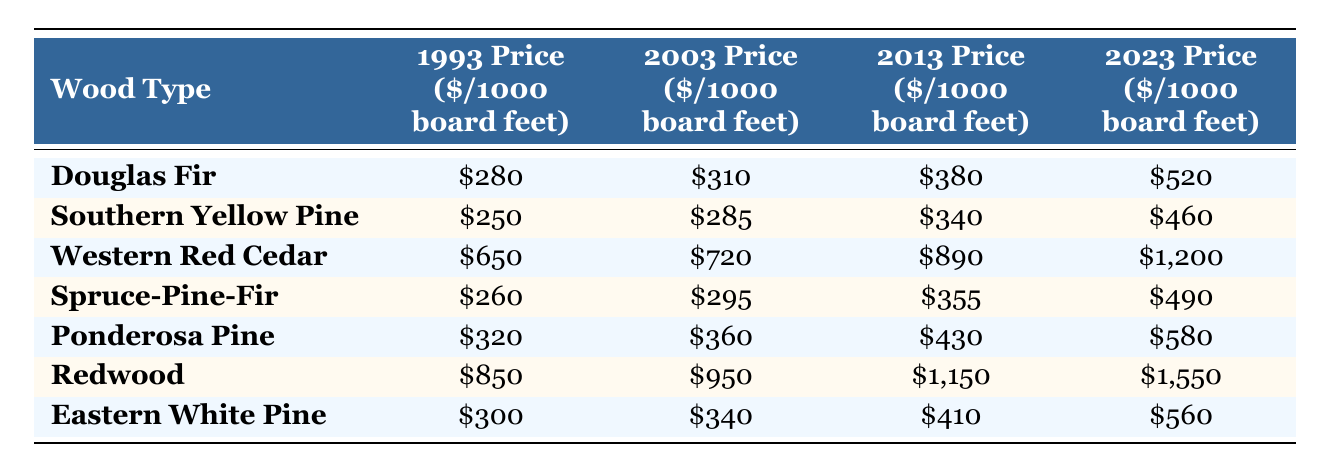What was the price of Western Red Cedar in 2023? The table shows that the price of Western Red Cedar in 2023 is listed under the respective column, which shows \$1,200.
Answer: $1,200 Which wood type had the lowest price in 1993? By examining the 1993 prices for all wood types, the lowest price is seen in Southern Yellow Pine, which is \$250.
Answer: Southern Yellow Pine What is the price difference of Redwood from 1993 to 2023? To find the price difference, subtract the 1993 price of Redwood (\$850) from its 2023 price (\$1,550). The calculation is \$1,550 - \$850 = \$700.
Answer: $700 Did Spruce-Pine-Fir have a higher price in 2013 than Southern Yellow Pine? Checking the prices, Spruce-Pine-Fir in 2013 is \$355, while Southern Yellow Pine is \$340. Since \$355 is greater than \$340, the answer is yes.
Answer: Yes What is the average price of Douglas Fir and Ponderosa Pine in 2023? To find the average, first add the 2023 prices of Douglas Fir (\$520) and Ponderosa Pine (\$580). This sums to \$520 + \$580 = \$1,100. Then, divide by 2 to get the average: \$1,100 / 2 = \$550.
Answer: $550 Which wood type experienced the highest increase in price from 1993 to 2023? The increase for each wood type is calculated by subtracting the 1993 price from the 2023 price. For Redwood, the increase is \$700; for Western Red Cedar, it's \$550; for Douglas Fir, it's \$240; etc. Comparing all increases, Redwood had the highest increase of \$700.
Answer: Redwood Was the price of Eastern White Pine in 2003 more than \$300? The price in 2003 for Eastern White Pine is \$340, which is indeed more than \$300, so the answer is yes.
Answer: Yes What wood type has the second highest price in 2013? By listing the 2013 prices from highest to lowest, the prices are: Redwood (\$1,150), Western Red Cedar (\$890), Douglas Fir (\$380), etc. Therefore, Western Red Cedar is the second highest at \$890.
Answer: Western Red Cedar 